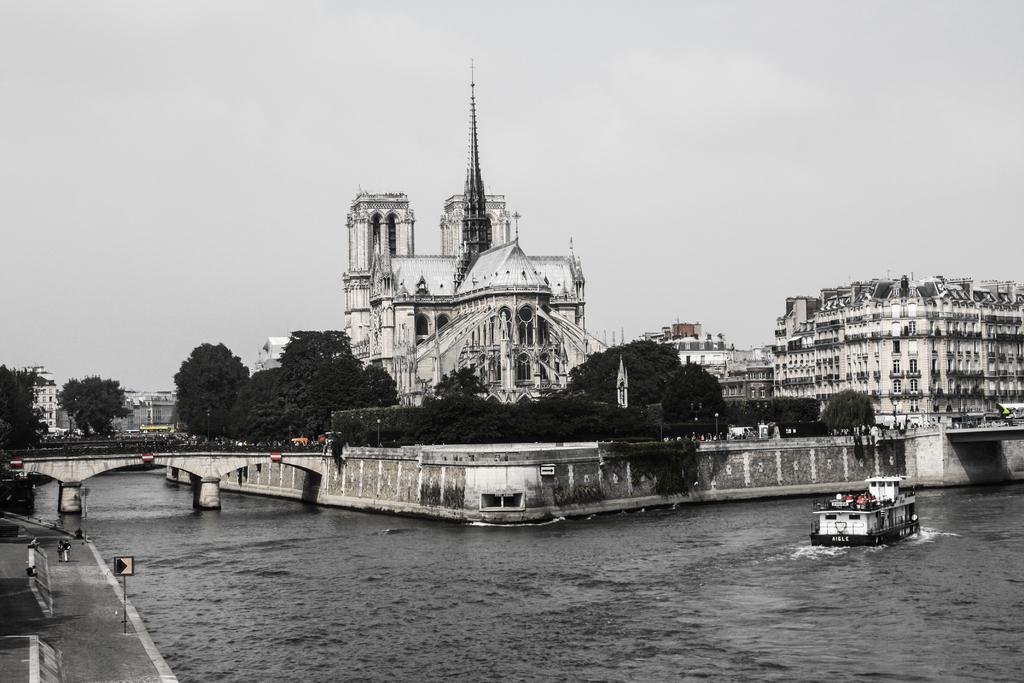Can you describe this image briefly? In this image we can see buildings, trees. There is a bridge. There is a ship in water. At the top of the image there is sky. 